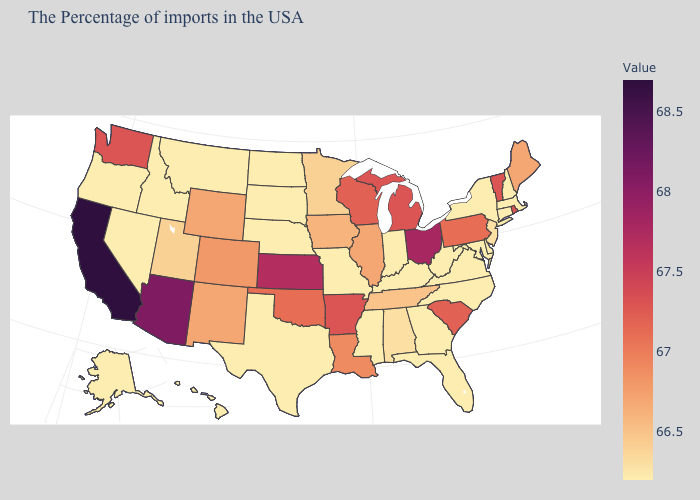Does Wisconsin have the lowest value in the MidWest?
Write a very short answer. No. Is the legend a continuous bar?
Write a very short answer. Yes. Does West Virginia have a lower value than Iowa?
Give a very brief answer. Yes. Which states hav the highest value in the South?
Write a very short answer. Arkansas. Does Washington have the highest value in the West?
Be succinct. No. 